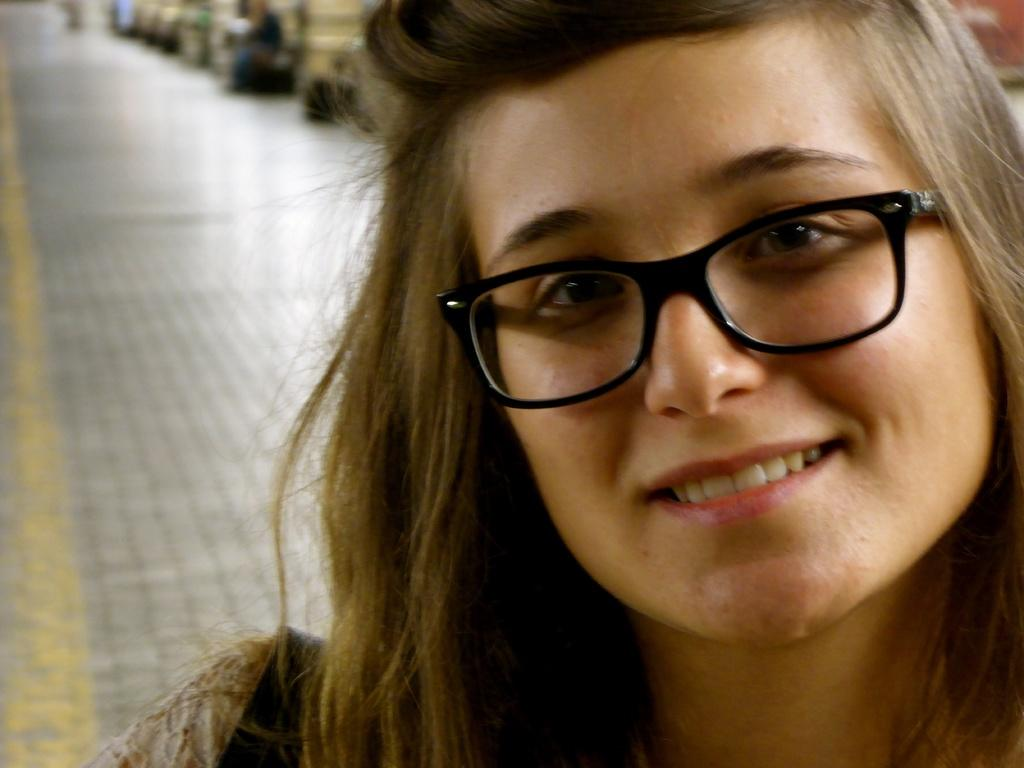Who is the main subject in the image? There is a woman in the image. What is the woman wearing on her face? The woman is wearing spectacles. What part of the woman's body is visible in the image? Only the woman's face is visible in the image. How is the background of the image depicted? The background of the woman is blurred. What type of bulb is illuminating the woman's face in the image? There is no bulb present in the image; it is a photograph or digital image, not a scene illuminated by a light source. What type of engine is powering the woman's spectacles in the image? There is no engine present in the image; the spectacles are a static object, not a powered device. 